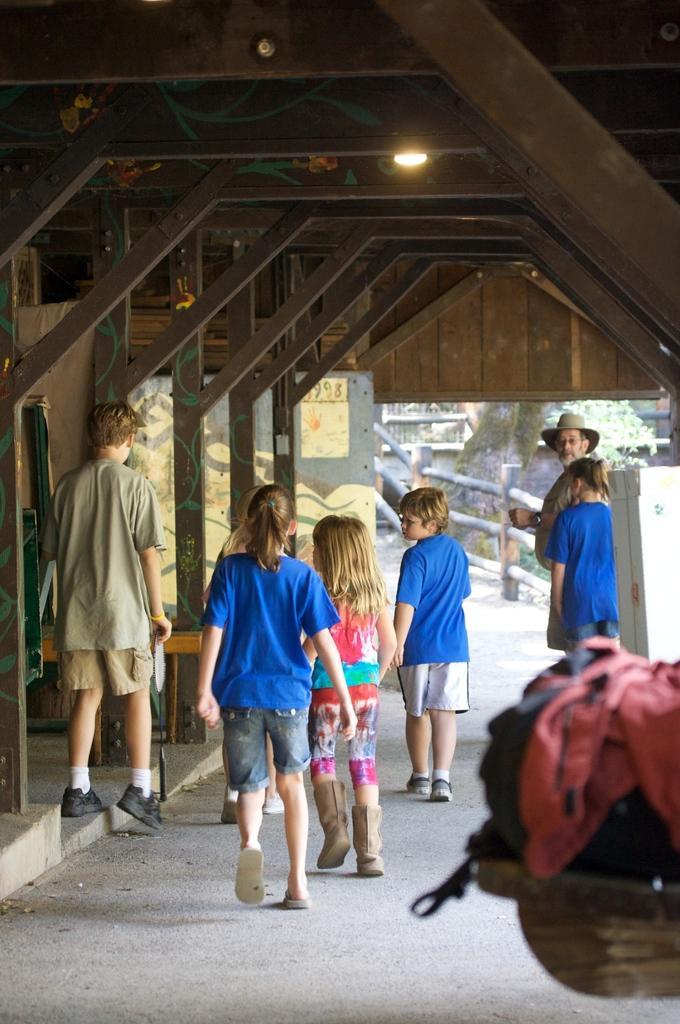In one or two sentences, can you explain what this image depicts? In this image I can see few children are walking and in the background I can see a man is standing and I can see he is wearing a hat. On the top of this image I can see a light and on the bottom right side I can see a red colour thing. I can also see three of them are wearing blue colour dress. 